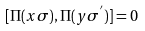<formula> <loc_0><loc_0><loc_500><loc_500>[ \Pi ( { x } \sigma ) , \Pi ( { y } \sigma ^ { ^ { \prime } } ) ] = 0</formula> 